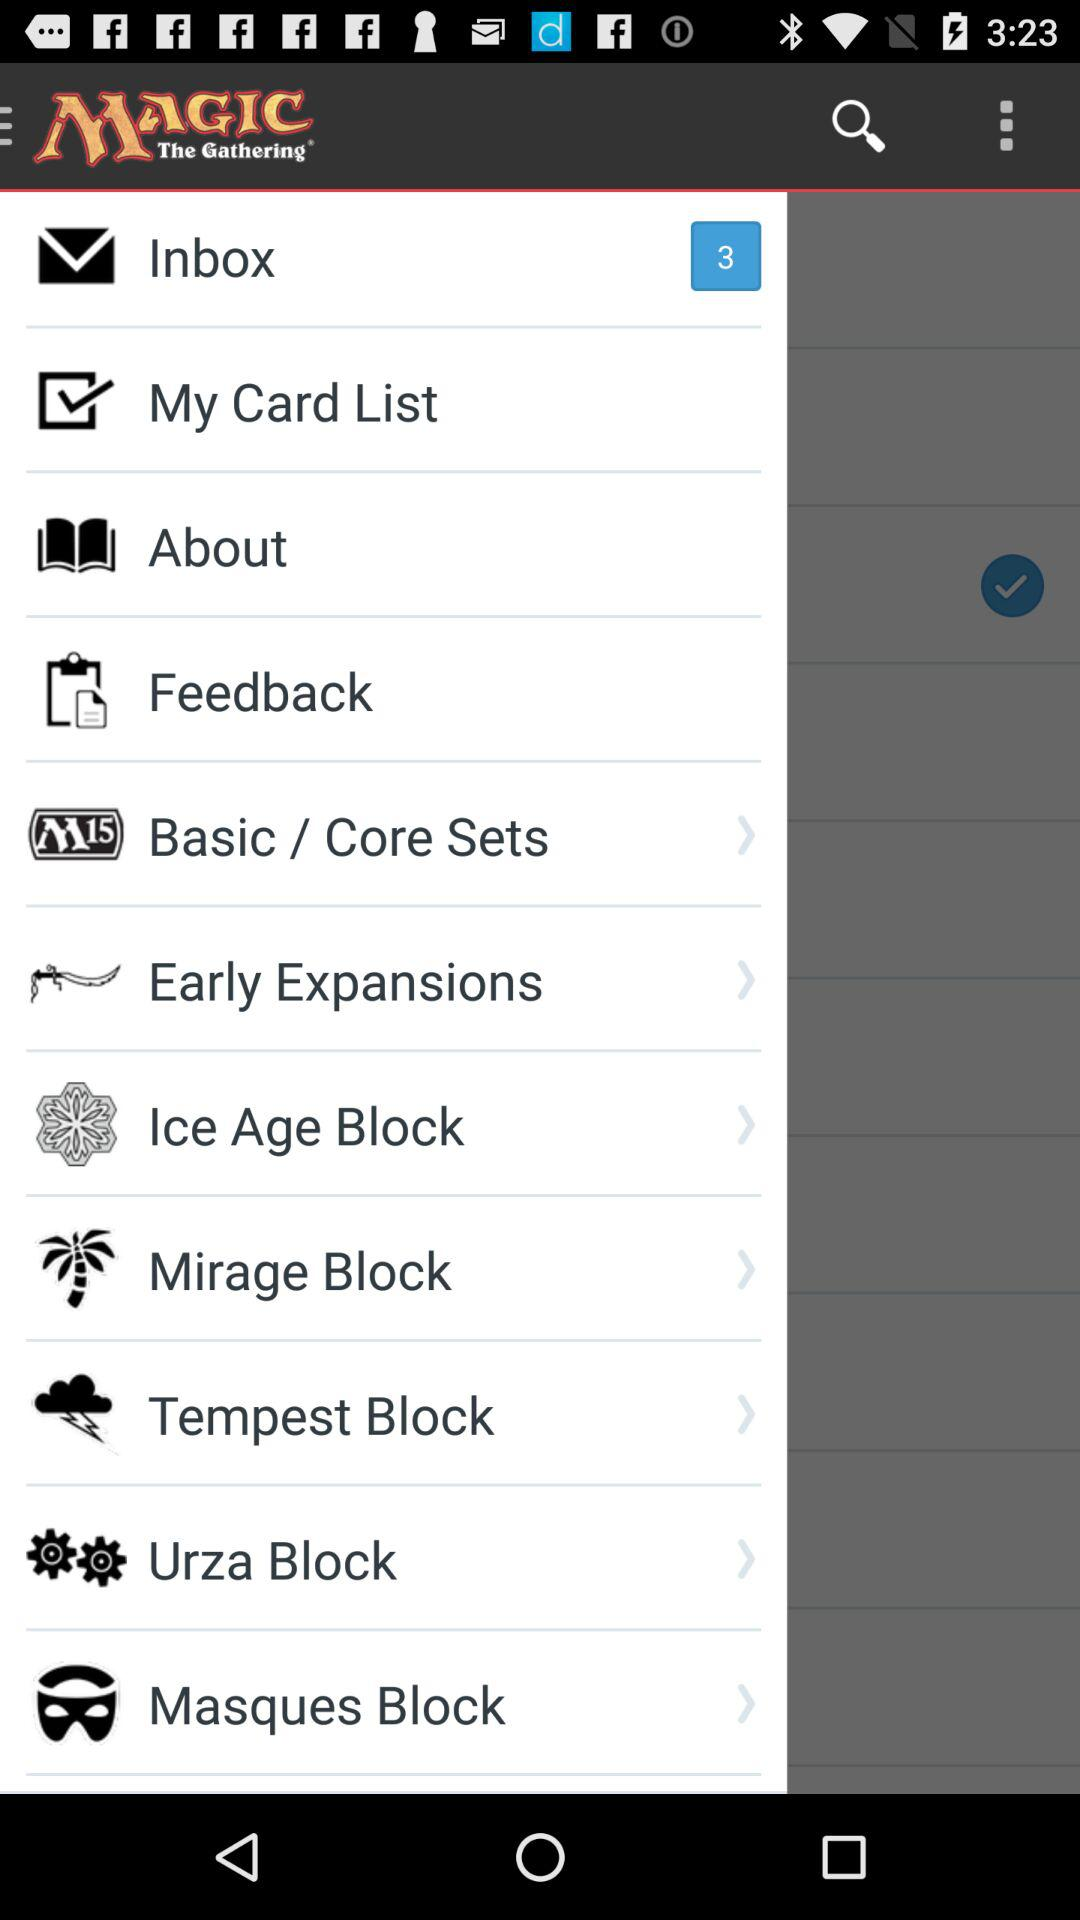How many unread messages are in the inbox? There are 3 unread messages in the inbox. 